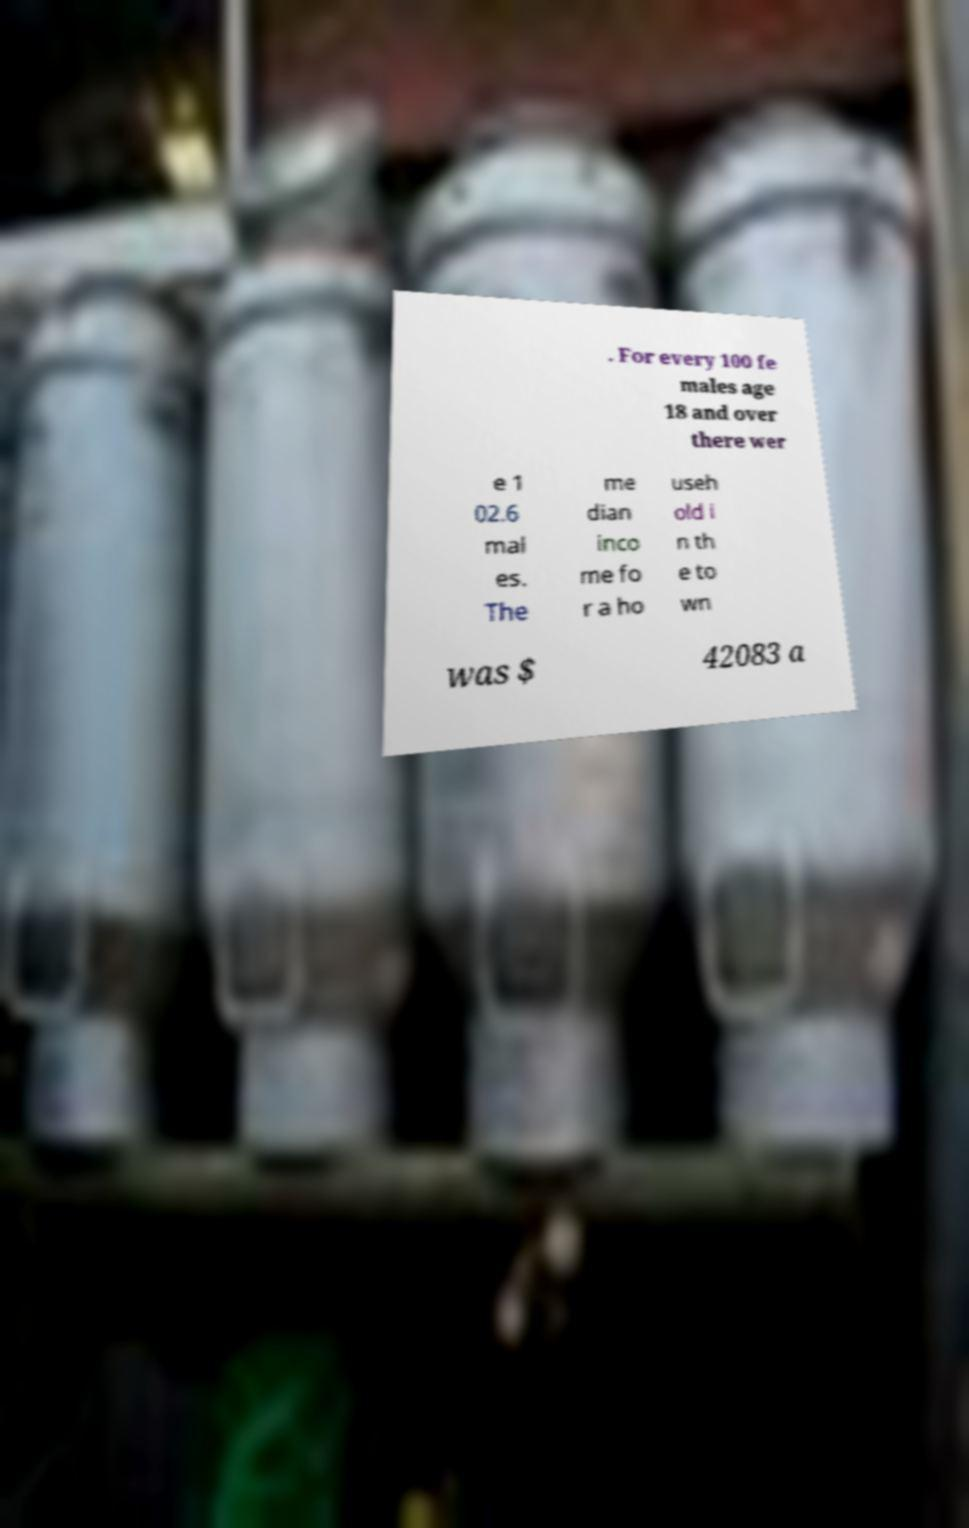Can you read and provide the text displayed in the image?This photo seems to have some interesting text. Can you extract and type it out for me? . For every 100 fe males age 18 and over there wer e 1 02.6 mal es. The me dian inco me fo r a ho useh old i n th e to wn was $ 42083 a 